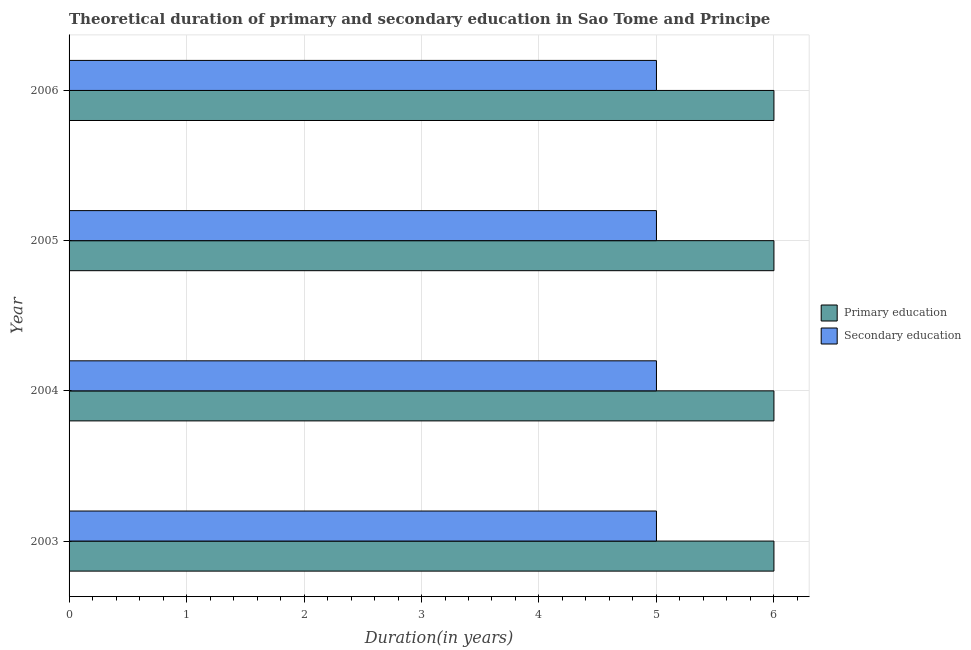How many different coloured bars are there?
Ensure brevity in your answer.  2. How many groups of bars are there?
Provide a succinct answer. 4. Are the number of bars per tick equal to the number of legend labels?
Offer a terse response. Yes. Are the number of bars on each tick of the Y-axis equal?
Ensure brevity in your answer.  Yes. How many bars are there on the 2nd tick from the bottom?
Keep it short and to the point. 2. In how many cases, is the number of bars for a given year not equal to the number of legend labels?
Your answer should be compact. 0. What is the duration of secondary education in 2006?
Your response must be concise. 5. Across all years, what is the maximum duration of secondary education?
Your answer should be very brief. 5. Across all years, what is the minimum duration of secondary education?
Keep it short and to the point. 5. In which year was the duration of secondary education minimum?
Give a very brief answer. 2003. What is the total duration of secondary education in the graph?
Make the answer very short. 20. What is the difference between the duration of primary education in 2006 and the duration of secondary education in 2005?
Your answer should be compact. 1. In the year 2003, what is the difference between the duration of secondary education and duration of primary education?
Offer a terse response. -1. What is the ratio of the duration of secondary education in 2004 to that in 2006?
Offer a very short reply. 1. Is the duration of primary education in 2004 less than that in 2006?
Offer a very short reply. No. Is the difference between the duration of secondary education in 2004 and 2005 greater than the difference between the duration of primary education in 2004 and 2005?
Offer a very short reply. No. What is the difference between the highest and the lowest duration of primary education?
Your answer should be compact. 0. Is the sum of the duration of secondary education in 2004 and 2005 greater than the maximum duration of primary education across all years?
Ensure brevity in your answer.  Yes. What does the 1st bar from the top in 2005 represents?
Offer a terse response. Secondary education. What does the 2nd bar from the bottom in 2006 represents?
Your response must be concise. Secondary education. How many years are there in the graph?
Your response must be concise. 4. Does the graph contain any zero values?
Your answer should be very brief. No. Does the graph contain grids?
Make the answer very short. Yes. How many legend labels are there?
Make the answer very short. 2. What is the title of the graph?
Provide a succinct answer. Theoretical duration of primary and secondary education in Sao Tome and Principe. Does "Services" appear as one of the legend labels in the graph?
Provide a succinct answer. No. What is the label or title of the X-axis?
Ensure brevity in your answer.  Duration(in years). What is the Duration(in years) of Primary education in 2003?
Make the answer very short. 6. What is the Duration(in years) of Secondary education in 2004?
Provide a succinct answer. 5. What is the Duration(in years) in Primary education in 2005?
Provide a succinct answer. 6. What is the Duration(in years) of Primary education in 2006?
Your answer should be compact. 6. What is the Duration(in years) in Secondary education in 2006?
Offer a very short reply. 5. Across all years, what is the maximum Duration(in years) in Primary education?
Give a very brief answer. 6. Across all years, what is the minimum Duration(in years) in Secondary education?
Your answer should be compact. 5. What is the total Duration(in years) of Primary education in the graph?
Provide a short and direct response. 24. What is the total Duration(in years) of Secondary education in the graph?
Ensure brevity in your answer.  20. What is the difference between the Duration(in years) of Secondary education in 2003 and that in 2004?
Make the answer very short. 0. What is the difference between the Duration(in years) in Primary education in 2003 and that in 2005?
Provide a succinct answer. 0. What is the difference between the Duration(in years) of Secondary education in 2003 and that in 2005?
Make the answer very short. 0. What is the difference between the Duration(in years) in Primary education in 2003 and that in 2006?
Give a very brief answer. 0. What is the difference between the Duration(in years) of Secondary education in 2003 and that in 2006?
Offer a terse response. 0. What is the difference between the Duration(in years) in Primary education in 2004 and that in 2005?
Your answer should be very brief. 0. What is the difference between the Duration(in years) of Primary education in 2004 and that in 2006?
Give a very brief answer. 0. What is the difference between the Duration(in years) of Primary education in 2005 and that in 2006?
Keep it short and to the point. 0. What is the difference between the Duration(in years) of Secondary education in 2005 and that in 2006?
Ensure brevity in your answer.  0. What is the difference between the Duration(in years) in Primary education in 2003 and the Duration(in years) in Secondary education in 2004?
Ensure brevity in your answer.  1. What is the difference between the Duration(in years) in Primary education in 2004 and the Duration(in years) in Secondary education in 2005?
Keep it short and to the point. 1. What is the difference between the Duration(in years) of Primary education in 2004 and the Duration(in years) of Secondary education in 2006?
Offer a terse response. 1. What is the difference between the Duration(in years) of Primary education in 2005 and the Duration(in years) of Secondary education in 2006?
Your response must be concise. 1. In the year 2003, what is the difference between the Duration(in years) of Primary education and Duration(in years) of Secondary education?
Your response must be concise. 1. In the year 2004, what is the difference between the Duration(in years) in Primary education and Duration(in years) in Secondary education?
Provide a short and direct response. 1. What is the ratio of the Duration(in years) in Primary education in 2003 to that in 2004?
Provide a short and direct response. 1. What is the ratio of the Duration(in years) in Secondary education in 2003 to that in 2004?
Offer a terse response. 1. What is the ratio of the Duration(in years) in Primary education in 2003 to that in 2005?
Your answer should be very brief. 1. What is the ratio of the Duration(in years) in Secondary education in 2003 to that in 2005?
Provide a short and direct response. 1. What is the ratio of the Duration(in years) of Secondary education in 2003 to that in 2006?
Give a very brief answer. 1. What is the ratio of the Duration(in years) in Primary education in 2005 to that in 2006?
Your answer should be very brief. 1. What is the ratio of the Duration(in years) in Secondary education in 2005 to that in 2006?
Your answer should be very brief. 1. What is the difference between the highest and the second highest Duration(in years) in Primary education?
Keep it short and to the point. 0. What is the difference between the highest and the second highest Duration(in years) in Secondary education?
Offer a very short reply. 0. What is the difference between the highest and the lowest Duration(in years) of Secondary education?
Keep it short and to the point. 0. 